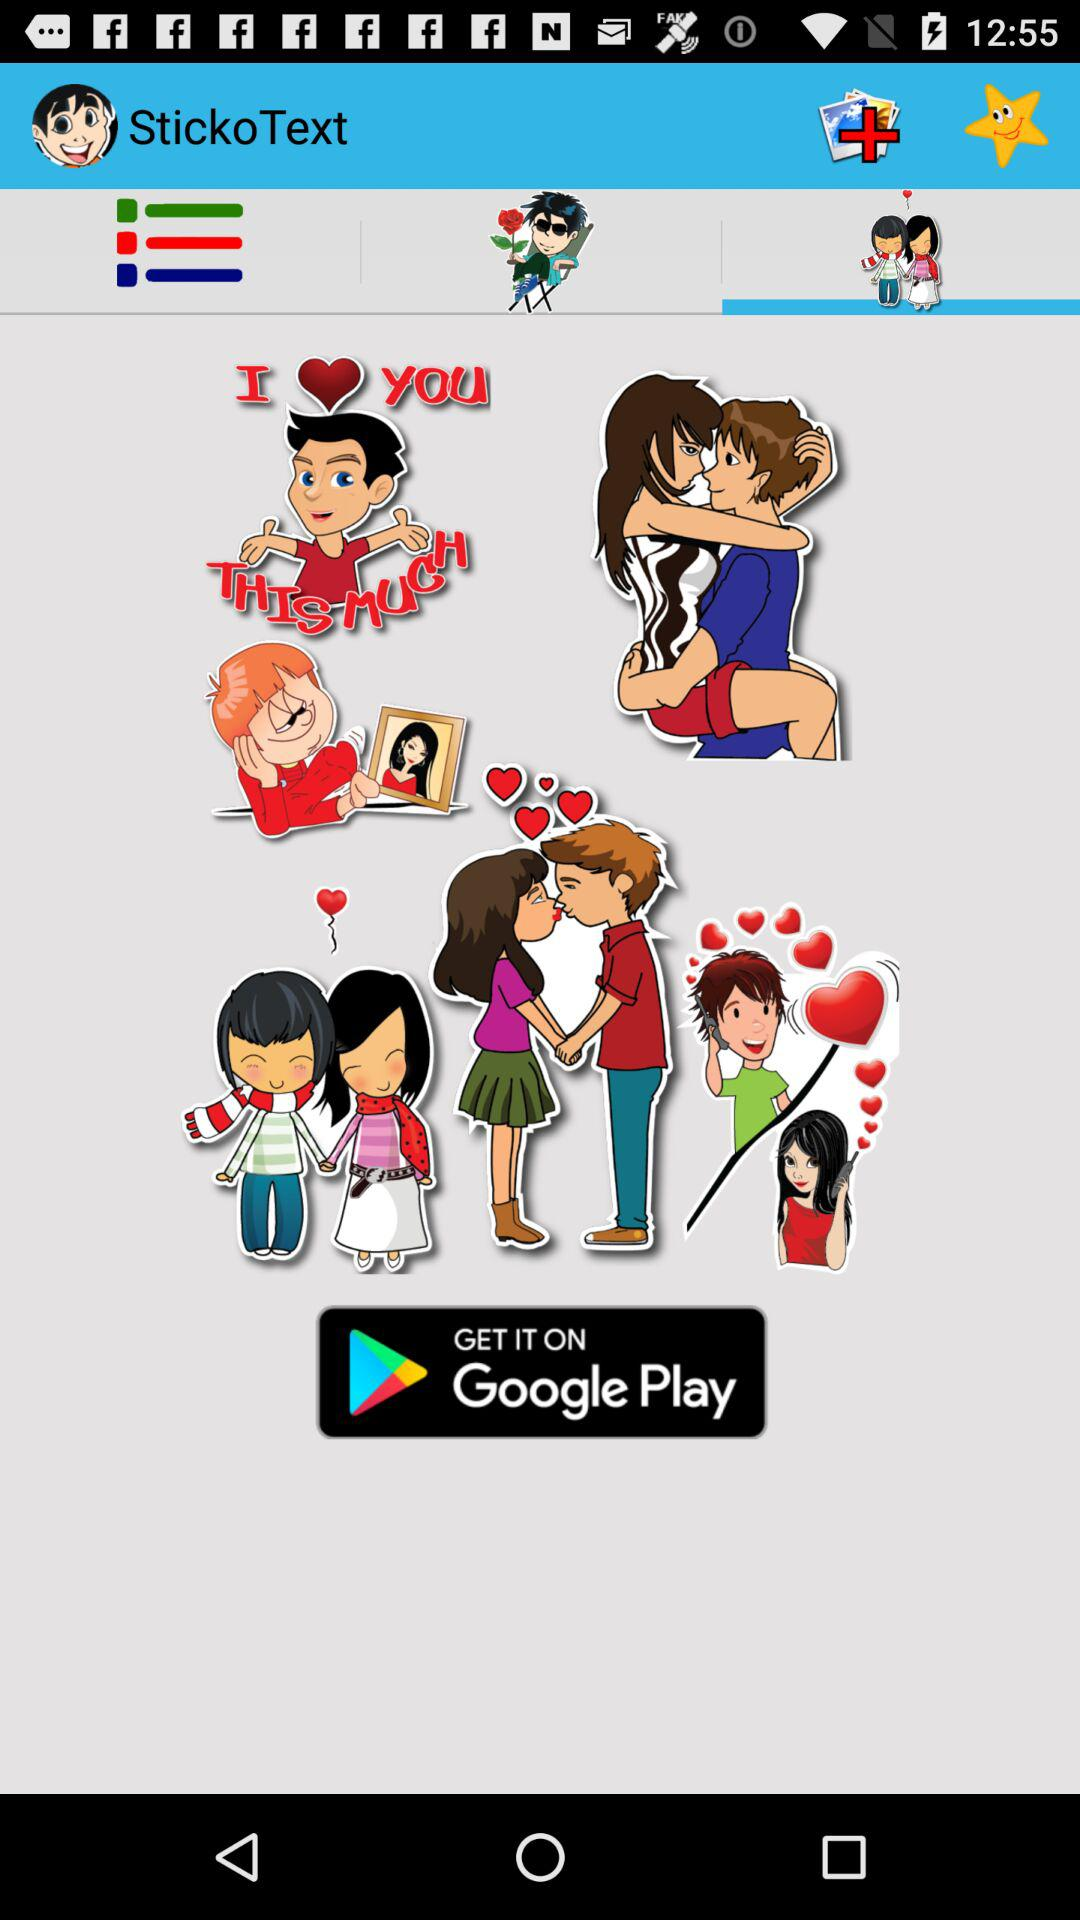What is the name of the application? The name of the application is "StickoText". 